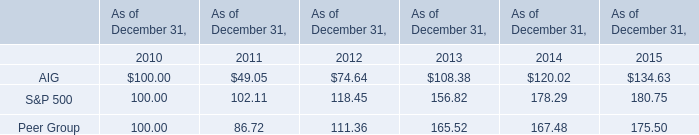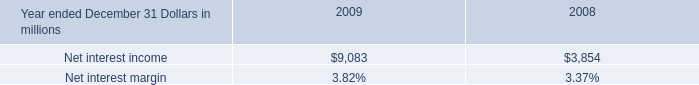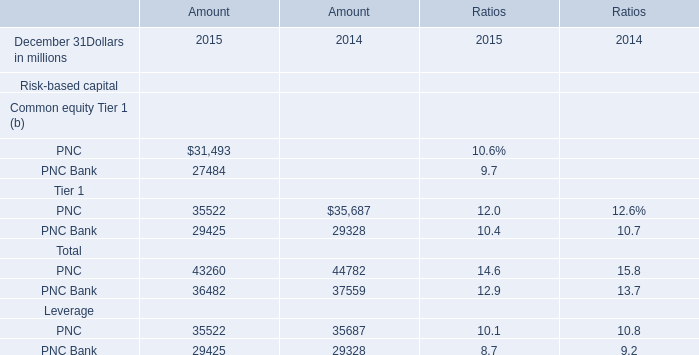In the year with lowest amount of PNC, what's the increasing rate of PNC Bank ? 
Computations: ((29425 - 29328) / 29425)
Answer: 0.0033. 